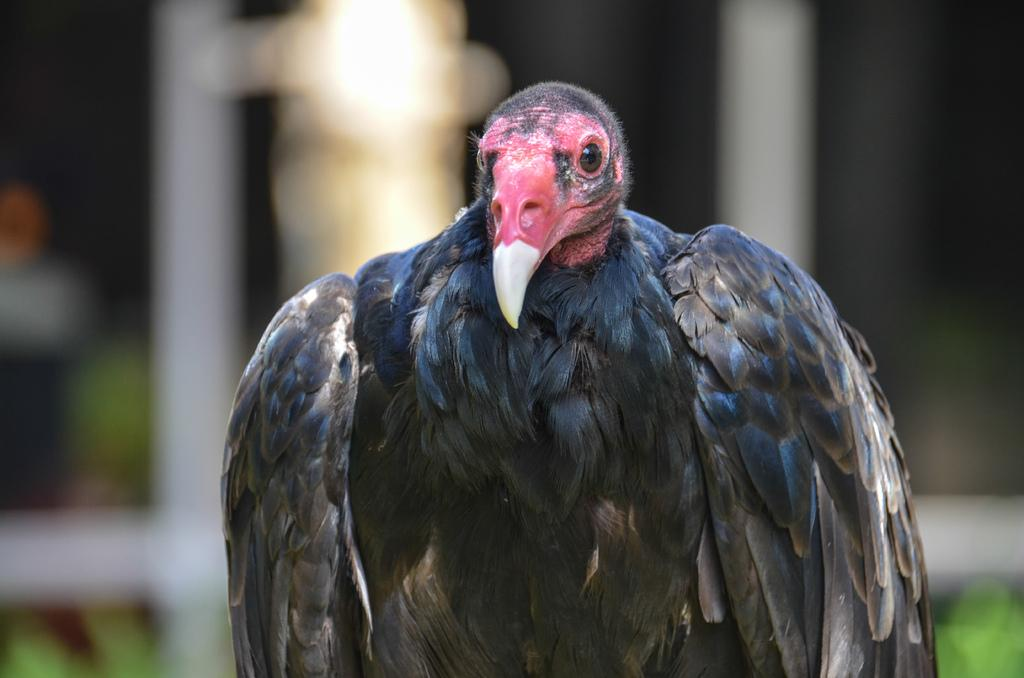What type of bird is in the picture? There is a turkey vulture in the picture. Can you describe the background of the image? The background of the image is blurred. What is the caption for the image? There is no caption provided with the image, so we cannot determine the caption. What record does the turkey vulture hold in the image? The image does not mention any records held by the turkey vulture, so we cannot determine any records. 